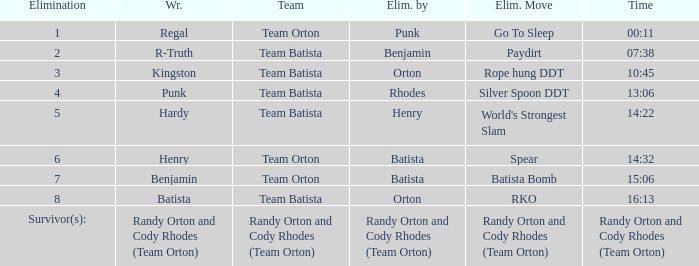Could you parse the entire table as a dict? {'header': ['Elimination', 'Wr.', 'Team', 'Elim. by', 'Elim. Move', 'Time'], 'rows': [['1', 'Regal', 'Team Orton', 'Punk', 'Go To Sleep', '00:11'], ['2', 'R-Truth', 'Team Batista', 'Benjamin', 'Paydirt', '07:38'], ['3', 'Kingston', 'Team Batista', 'Orton', 'Rope hung DDT', '10:45'], ['4', 'Punk', 'Team Batista', 'Rhodes', 'Silver Spoon DDT', '13:06'], ['5', 'Hardy', 'Team Batista', 'Henry', "World's Strongest Slam", '14:22'], ['6', 'Henry', 'Team Orton', 'Batista', 'Spear', '14:32'], ['7', 'Benjamin', 'Team Orton', 'Batista', 'Batista Bomb', '15:06'], ['8', 'Batista', 'Team Batista', 'Orton', 'RKO', '16:13'], ['Survivor(s):', 'Randy Orton and Cody Rhodes (Team Orton)', 'Randy Orton and Cody Rhodes (Team Orton)', 'Randy Orton and Cody Rhodes (Team Orton)', 'Randy Orton and Cody Rhodes (Team Orton)', 'Randy Orton and Cody Rhodes (Team Orton)']]} What Elimination Move is listed against Wrestler Henry, Eliminated by Batista? Spear. 